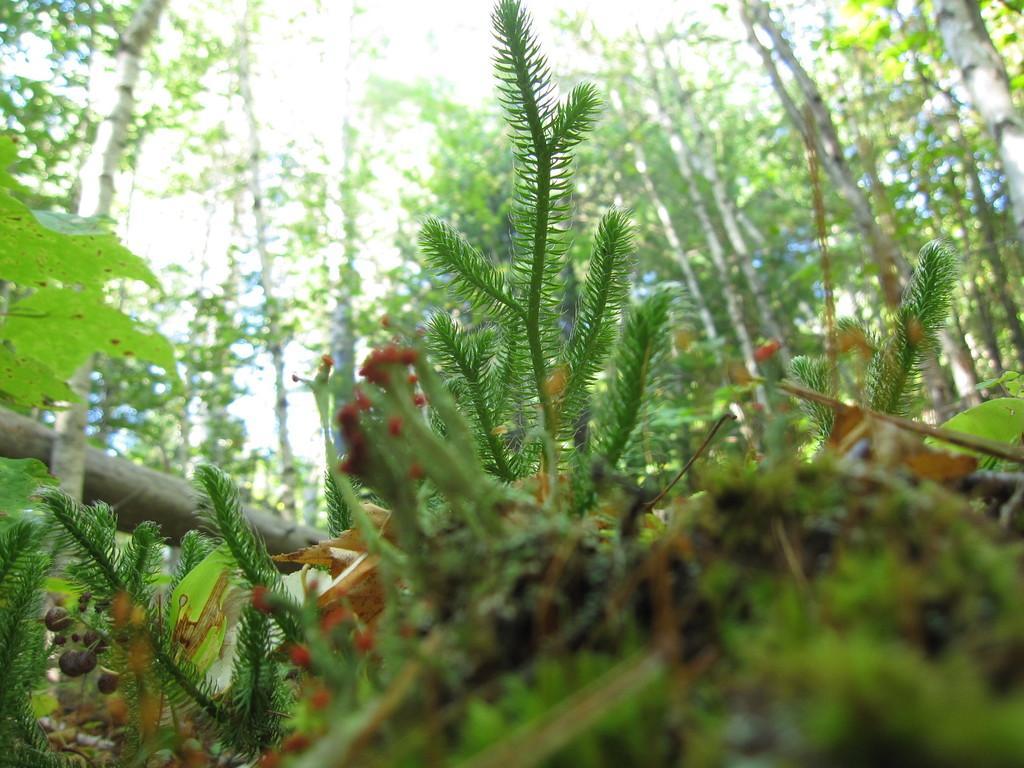What type of plants can be seen in the image? There are plants with flowers in the image. What color are the flowers on the plants? The flowers are red. What can be seen in the background of the image? There are trees in the background of the image. Can you describe the focus of the image? The bottom of the picture is blurred, suggesting that the focus is on the plants and flowers in the foreground. What nation is being discussed in the image? There is no discussion or reference to a nation in the image; it features plants with red flowers and trees in the background. 